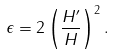Convert formula to latex. <formula><loc_0><loc_0><loc_500><loc_500>\epsilon = 2 \left ( \frac { H ^ { \prime } } { H } \right ) ^ { 2 } .</formula> 